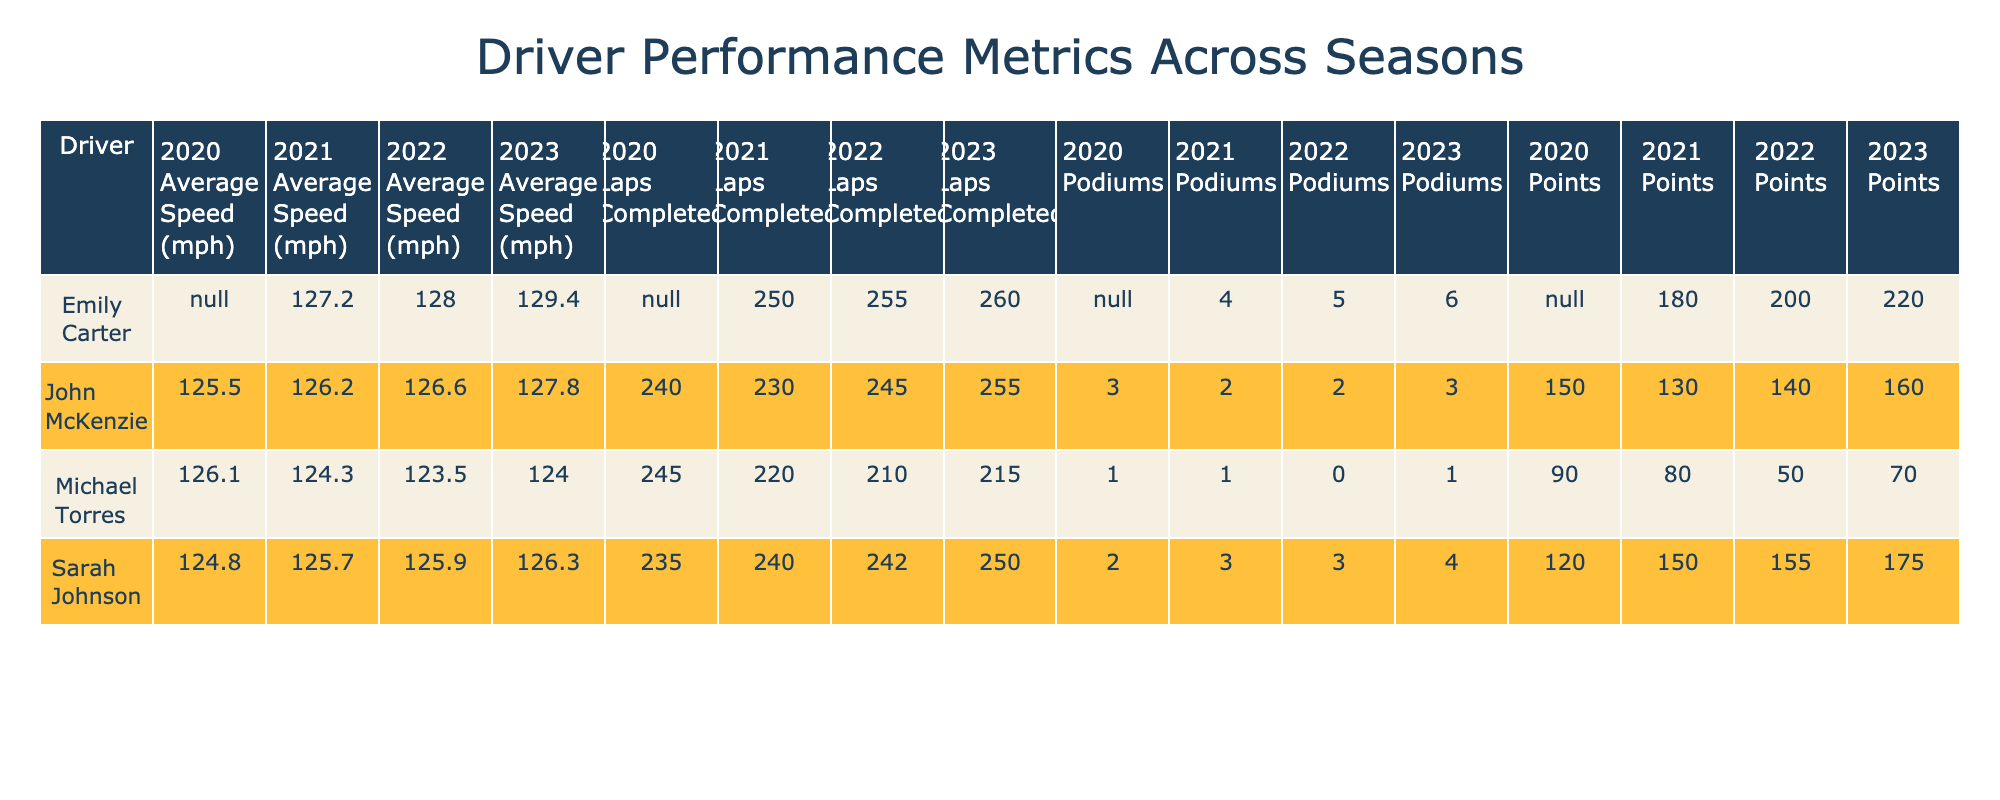What driver completed the most laps in 2023? Referring to the 2023 data, Emily Carter completed 260 laps, which is more than any other driver in that season.
Answer: Emily Carter How many points did Michael Torres score in 2021? According to the table, Michael Torres scored 80 points in the 2021 season.
Answer: 80 points Which driver had the highest average speed in 2022? Emily Carter had the highest average speed in 2022 at 128.0 mph, compared to other drivers in that season.
Answer: 128.0 mph What is the total number of podiums achieved by Sarah Johnson across all seasons? Summing her podiums: 2 (2020) + 3 (2021) + 3 (2022) + 4 (2023) = 12 podiums in total.
Answer: 12 Did John McKenzie score the most points in any single season? No, Emily Carter scored 220 points in 2023, which is more than John's highest score of 160 in 2023.
Answer: No How does John McKenzie’s average speed in 2021 compare to his average speed in 2022? John McKenzie had an average speed of 126.2 mph in 2021 and 126.6 mph in 2022; 126.6 is higher than 126.2.
Answer: Higher in 2022 What is the difference in total points between Emily Carter and Michael Torres in 2023? Emily Carter scored 220 points and Michael Torres scored 70 points in 2023. The difference is 220 - 70 = 150 points.
Answer: 150 points Who had the lowest number of laps completed in 2022? Michael Torres completed the fewest laps in 2022 with 210 laps, compared to others who completed more.
Answer: Michael Torres Which season had the overall highest podium count for the drivers? In 2023, the total podiums were 6 (Emily Carter) + 3 (John McKenzie) + 4 (Sarah Johnson) + 1 (Michael Torres) = 14. This is more than any other season's totals.
Answer: 2023 What is the average number of laps completed by Sarah Johnson across all seasons? Sarah Johnson completed: 235 (2020) + 240 (2021) + 242 (2022) + 250 (2023) = 967 laps. There are 4 seasons, so the average is 967 / 4 = 241.75 laps.
Answer: 241.75 laps 